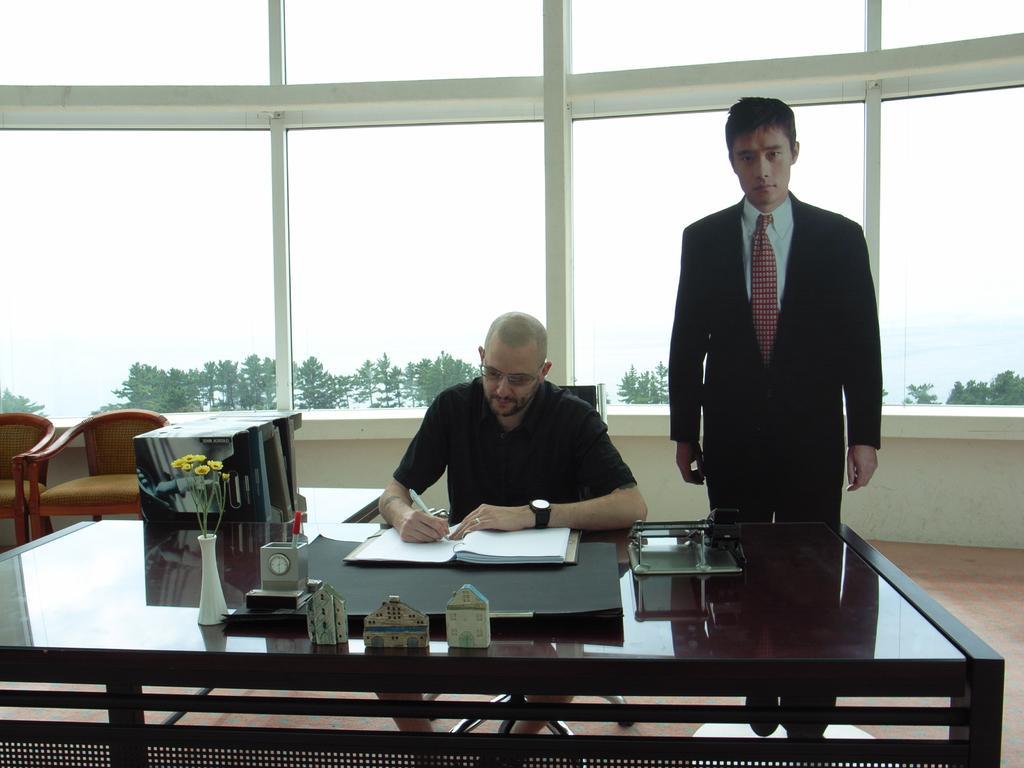Can you describe this image briefly? In this image i can see two man , a man sitting on the chair is writing on a book, the man standing here, in front of a man there are some chart, a clock, flower pot on a table, at the back ground i can see two chairs, a tree and a glass. 